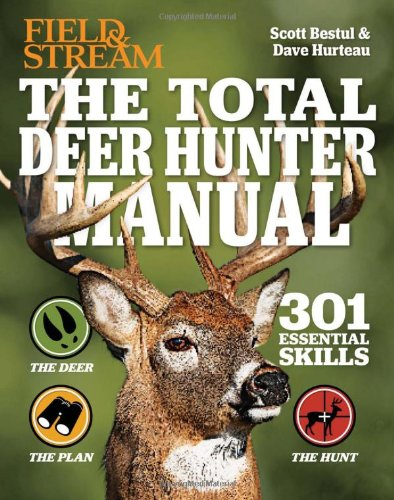Is this a motivational book? No, this book is not motivational in nature; it is specifically a practical manual focused on deer hunting techniques and strategies. 